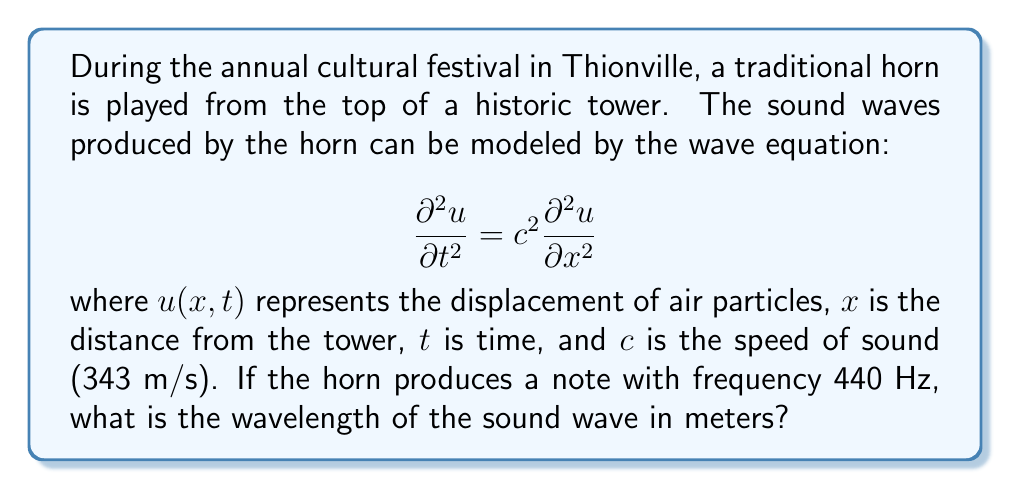Provide a solution to this math problem. To solve this problem, we'll follow these steps:

1) Recall the relationship between wavelength ($\lambda$), frequency ($f$), and wave speed ($c$):

   $$c = f\lambda$$

2) We are given:
   - Speed of sound: $c = 343$ m/s
   - Frequency: $f = 440$ Hz

3) Rearrange the equation to solve for wavelength:

   $$\lambda = \frac{c}{f}$$

4) Substitute the known values:

   $$\lambda = \frac{343 \text{ m/s}}{440 \text{ Hz}}$$

5) Perform the division:

   $$\lambda = 0.77954545... \text{ m}$$

6) Round to two decimal places for a reasonable level of precision:

   $$\lambda \approx 0.78 \text{ m}$$

Thus, the wavelength of the sound wave is approximately 0.78 meters.
Answer: 0.78 m 